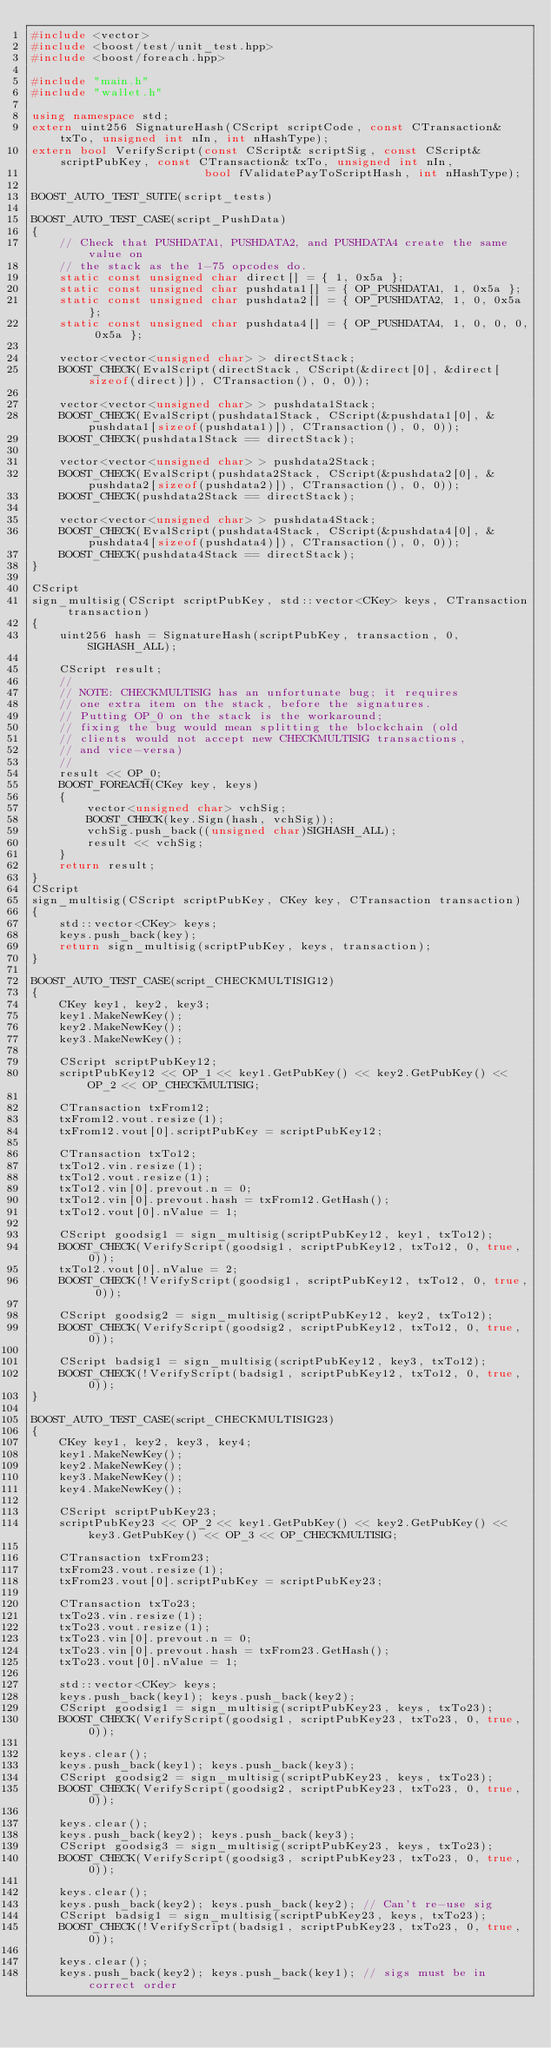Convert code to text. <code><loc_0><loc_0><loc_500><loc_500><_C++_>#include <vector>
#include <boost/test/unit_test.hpp>
#include <boost/foreach.hpp>

#include "main.h"
#include "wallet.h"

using namespace std;
extern uint256 SignatureHash(CScript scriptCode, const CTransaction& txTo, unsigned int nIn, int nHashType);
extern bool VerifyScript(const CScript& scriptSig, const CScript& scriptPubKey, const CTransaction& txTo, unsigned int nIn,
                         bool fValidatePayToScriptHash, int nHashType);

BOOST_AUTO_TEST_SUITE(script_tests)

BOOST_AUTO_TEST_CASE(script_PushData)
{
    // Check that PUSHDATA1, PUSHDATA2, and PUSHDATA4 create the same value on
    // the stack as the 1-75 opcodes do.
    static const unsigned char direct[] = { 1, 0x5a };
    static const unsigned char pushdata1[] = { OP_PUSHDATA1, 1, 0x5a };
    static const unsigned char pushdata2[] = { OP_PUSHDATA2, 1, 0, 0x5a };
    static const unsigned char pushdata4[] = { OP_PUSHDATA4, 1, 0, 0, 0, 0x5a };

    vector<vector<unsigned char> > directStack;
    BOOST_CHECK(EvalScript(directStack, CScript(&direct[0], &direct[sizeof(direct)]), CTransaction(), 0, 0));

    vector<vector<unsigned char> > pushdata1Stack;
    BOOST_CHECK(EvalScript(pushdata1Stack, CScript(&pushdata1[0], &pushdata1[sizeof(pushdata1)]), CTransaction(), 0, 0));
    BOOST_CHECK(pushdata1Stack == directStack);

    vector<vector<unsigned char> > pushdata2Stack;
    BOOST_CHECK(EvalScript(pushdata2Stack, CScript(&pushdata2[0], &pushdata2[sizeof(pushdata2)]), CTransaction(), 0, 0));
    BOOST_CHECK(pushdata2Stack == directStack);

    vector<vector<unsigned char> > pushdata4Stack;
    BOOST_CHECK(EvalScript(pushdata4Stack, CScript(&pushdata4[0], &pushdata4[sizeof(pushdata4)]), CTransaction(), 0, 0));
    BOOST_CHECK(pushdata4Stack == directStack);
}

CScript
sign_multisig(CScript scriptPubKey, std::vector<CKey> keys, CTransaction transaction)
{
    uint256 hash = SignatureHash(scriptPubKey, transaction, 0, SIGHASH_ALL);

    CScript result;
    //
    // NOTE: CHECKMULTISIG has an unfortunate bug; it requires
    // one extra item on the stack, before the signatures.
    // Putting OP_0 on the stack is the workaround;
    // fixing the bug would mean splitting the blockchain (old
    // clients would not accept new CHECKMULTISIG transactions,
    // and vice-versa)
    //
    result << OP_0;
    BOOST_FOREACH(CKey key, keys)
    {
        vector<unsigned char> vchSig;
        BOOST_CHECK(key.Sign(hash, vchSig));
        vchSig.push_back((unsigned char)SIGHASH_ALL);
        result << vchSig;
    }
    return result;
}
CScript
sign_multisig(CScript scriptPubKey, CKey key, CTransaction transaction)
{
    std::vector<CKey> keys;
    keys.push_back(key);
    return sign_multisig(scriptPubKey, keys, transaction);
}

BOOST_AUTO_TEST_CASE(script_CHECKMULTISIG12)
{
    CKey key1, key2, key3;
    key1.MakeNewKey();
    key2.MakeNewKey();
    key3.MakeNewKey();

    CScript scriptPubKey12;
    scriptPubKey12 << OP_1 << key1.GetPubKey() << key2.GetPubKey() << OP_2 << OP_CHECKMULTISIG;

    CTransaction txFrom12;
    txFrom12.vout.resize(1);
    txFrom12.vout[0].scriptPubKey = scriptPubKey12;

    CTransaction txTo12;
    txTo12.vin.resize(1);
    txTo12.vout.resize(1);
    txTo12.vin[0].prevout.n = 0;
    txTo12.vin[0].prevout.hash = txFrom12.GetHash();
    txTo12.vout[0].nValue = 1;

    CScript goodsig1 = sign_multisig(scriptPubKey12, key1, txTo12);
    BOOST_CHECK(VerifyScript(goodsig1, scriptPubKey12, txTo12, 0, true, 0));
    txTo12.vout[0].nValue = 2;
    BOOST_CHECK(!VerifyScript(goodsig1, scriptPubKey12, txTo12, 0, true, 0));

    CScript goodsig2 = sign_multisig(scriptPubKey12, key2, txTo12);
    BOOST_CHECK(VerifyScript(goodsig2, scriptPubKey12, txTo12, 0, true, 0));

    CScript badsig1 = sign_multisig(scriptPubKey12, key3, txTo12);
    BOOST_CHECK(!VerifyScript(badsig1, scriptPubKey12, txTo12, 0, true, 0));
}

BOOST_AUTO_TEST_CASE(script_CHECKMULTISIG23)
{
    CKey key1, key2, key3, key4;
    key1.MakeNewKey();
    key2.MakeNewKey();
    key3.MakeNewKey();
    key4.MakeNewKey();

    CScript scriptPubKey23;
    scriptPubKey23 << OP_2 << key1.GetPubKey() << key2.GetPubKey() << key3.GetPubKey() << OP_3 << OP_CHECKMULTISIG;

    CTransaction txFrom23;
    txFrom23.vout.resize(1);
    txFrom23.vout[0].scriptPubKey = scriptPubKey23;

    CTransaction txTo23;
    txTo23.vin.resize(1);
    txTo23.vout.resize(1);
    txTo23.vin[0].prevout.n = 0;
    txTo23.vin[0].prevout.hash = txFrom23.GetHash();
    txTo23.vout[0].nValue = 1;

    std::vector<CKey> keys;
    keys.push_back(key1); keys.push_back(key2);
    CScript goodsig1 = sign_multisig(scriptPubKey23, keys, txTo23);
    BOOST_CHECK(VerifyScript(goodsig1, scriptPubKey23, txTo23, 0, true, 0));

    keys.clear();
    keys.push_back(key1); keys.push_back(key3);
    CScript goodsig2 = sign_multisig(scriptPubKey23, keys, txTo23);
    BOOST_CHECK(VerifyScript(goodsig2, scriptPubKey23, txTo23, 0, true, 0));

    keys.clear();
    keys.push_back(key2); keys.push_back(key3);
    CScript goodsig3 = sign_multisig(scriptPubKey23, keys, txTo23);
    BOOST_CHECK(VerifyScript(goodsig3, scriptPubKey23, txTo23, 0, true, 0));

    keys.clear();
    keys.push_back(key2); keys.push_back(key2); // Can't re-use sig
    CScript badsig1 = sign_multisig(scriptPubKey23, keys, txTo23);
    BOOST_CHECK(!VerifyScript(badsig1, scriptPubKey23, txTo23, 0, true, 0));

    keys.clear();
    keys.push_back(key2); keys.push_back(key1); // sigs must be in correct order</code> 